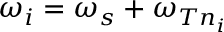<formula> <loc_0><loc_0><loc_500><loc_500>\omega _ { i } = \omega _ { s } + \omega _ { T n _ { i } }</formula> 